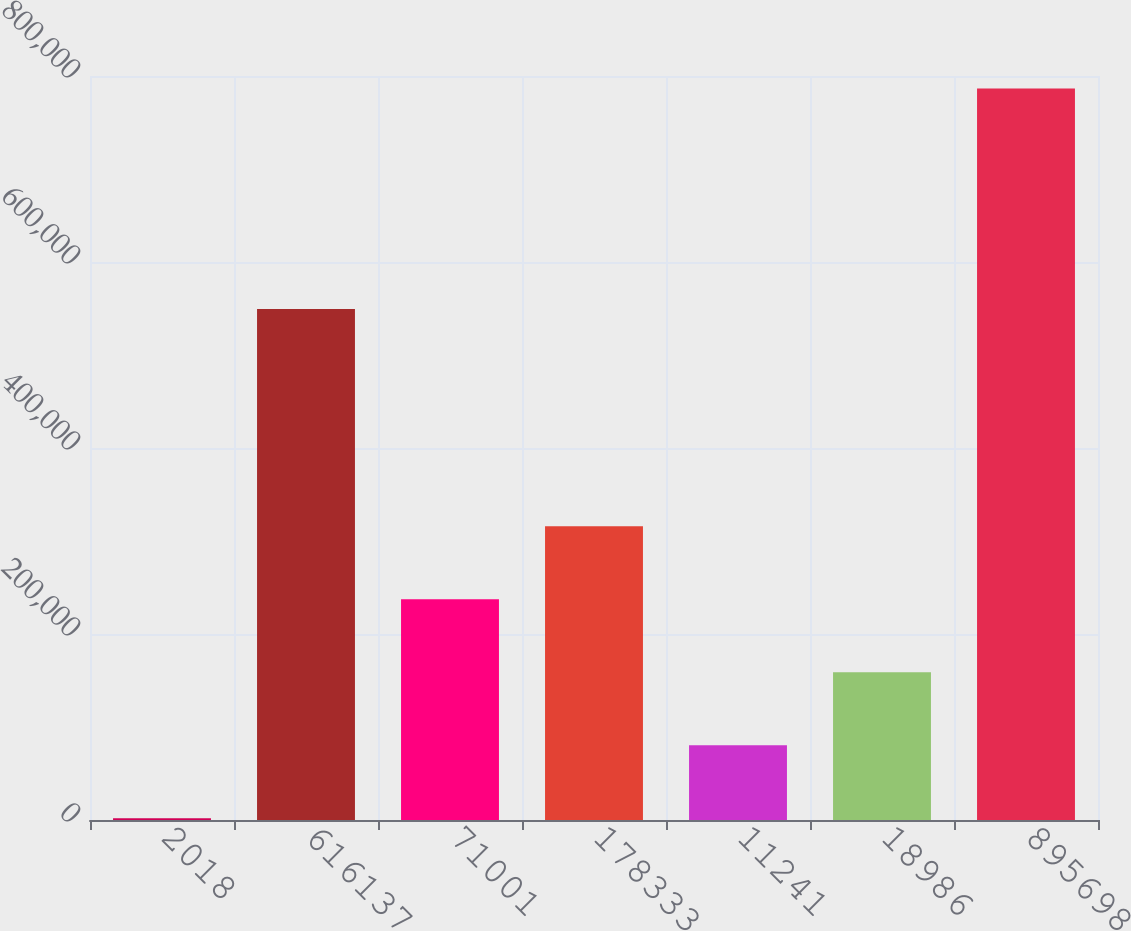Convert chart. <chart><loc_0><loc_0><loc_500><loc_500><bar_chart><fcel>2018<fcel>616137<fcel>71001<fcel>178333<fcel>11241<fcel>18986<fcel>895698<nl><fcel>2016<fcel>549552<fcel>237386<fcel>315843<fcel>80472.7<fcel>158929<fcel>786583<nl></chart> 